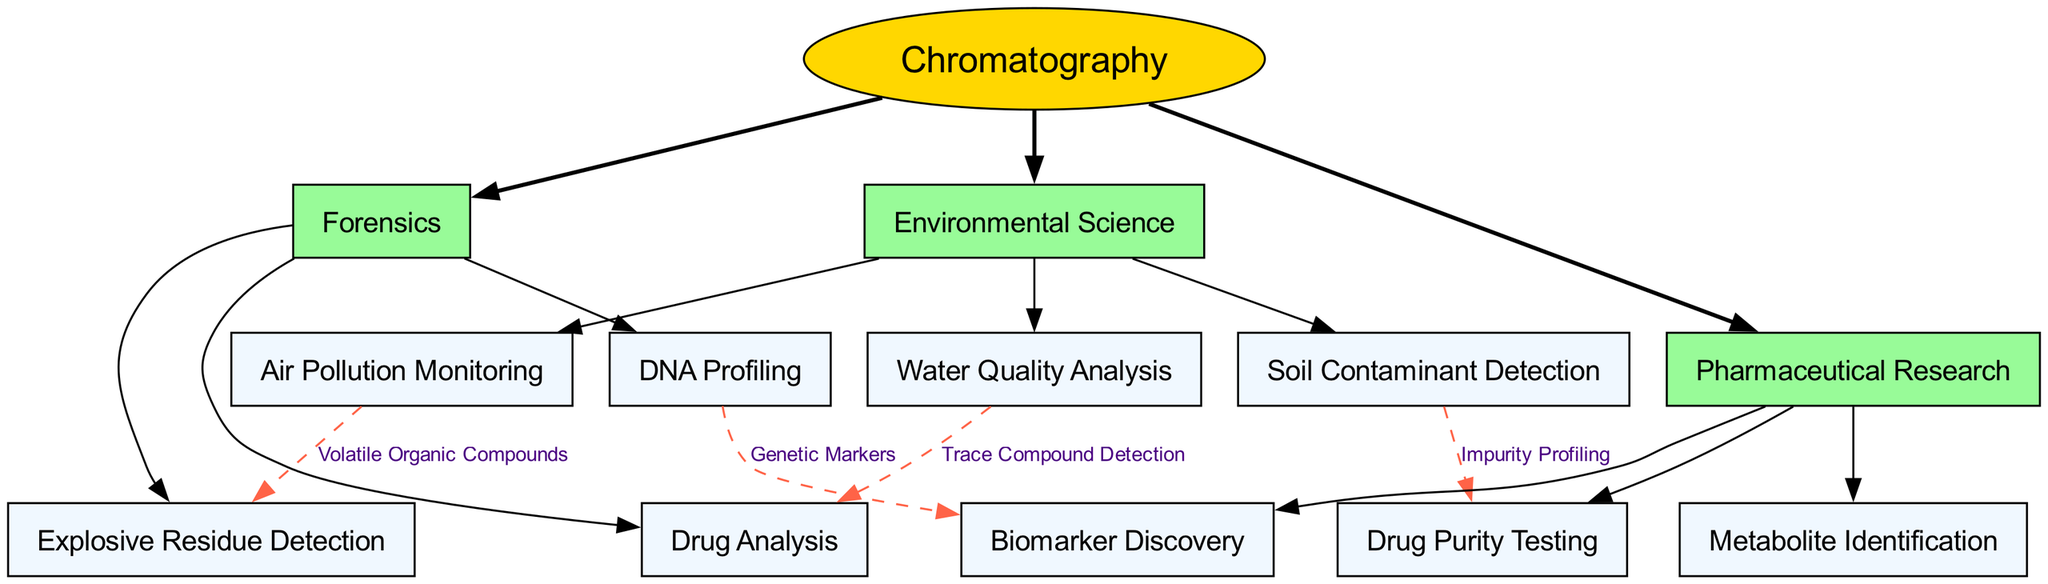What is the central node in the diagram? The central node, which is the main topic of the diagram, is identified at the center of the structure and is labeled "Chromatography".
Answer: Chromatography How many main branches are in the diagram? The diagram has three main branches that stem from the central node, which can be counted by examining the first level of connections.
Answer: 3 What are the sub-nodes under Environmental Science? To find the sub-nodes under Environmental Science, one should look below that branch, which lists "Water Quality Analysis", "Air Pollution Monitoring", and "Soil Contaminant Detection".
Answer: Water Quality Analysis, Air Pollution Monitoring, Soil Contaminant Detection What is the connection label between Water Quality Analysis and Drug Analysis? The label that represents the relationship between the two specified sub-nodes is shown on the edge connecting them, defining the purpose of the connection as "Trace Compound Detection".
Answer: Trace Compound Detection Which sub-node in Forensics is connected to DNA Profiling? By analyzing the edges extending from the DNA Profiling node, the connection leads to a specific node in the Pharmaceutical Research branch, indicating the relationship formed by the edges. The connected node is "Biomarker Discovery".
Answer: Biomarker Discovery How many sub-nodes are listed under Pharmaceutical Research? The number of sub-nodes can be confirmed by counting the listed items under the Pharmaceutical Research branch, specifically "Drug Purity Testing", "Metabolite Identification", and "Biomarker Discovery".
Answer: 3 Which fields has connections related to Volatile Organic Compounds? The connection involving Volatile Organic Compounds can be traced from the sub-node related to Air Pollution Monitoring to its corresponding Forensics sub-node, which is "Explosive Residue Detection".
Answer: Explosive Residue Detection What is the relationship between Soil Contaminant Detection and Drug Purity Testing? The relationship can be directly observed from the connection line labeled which indicates that the link exists due to the nature of the analysis being performed on impurities, termed here as "Impurity Profiling".
Answer: Impurity Profiling What are the main applications of chromatography in the field of Forensics? The main applications are evident from the sub-nodes directly linked under Forensics, which are "Drug Analysis", "Explosive Residue Detection", and "DNA Profiling".
Answer: Drug Analysis, Explosive Residue Detection, DNA Profiling 